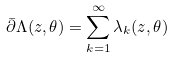<formula> <loc_0><loc_0><loc_500><loc_500>\bar { \partial } \Lambda ( z , \theta ) = \sum _ { k = 1 } ^ { \infty } \lambda _ { k } ( z , \theta )</formula> 